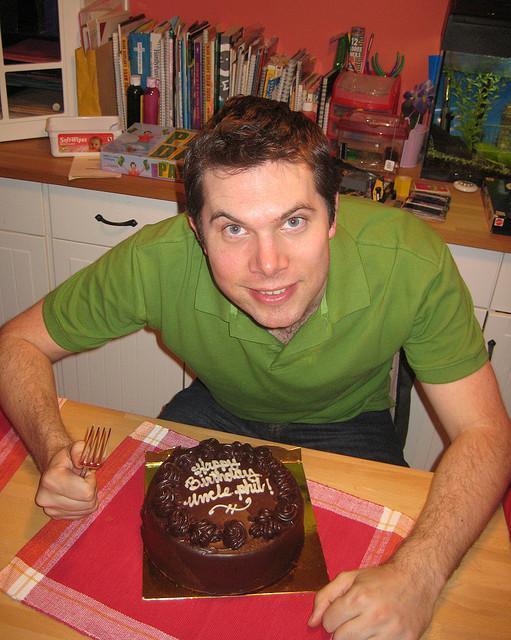Does the image validate the caption "The person is close to the cake."?
Answer yes or no. Yes. 